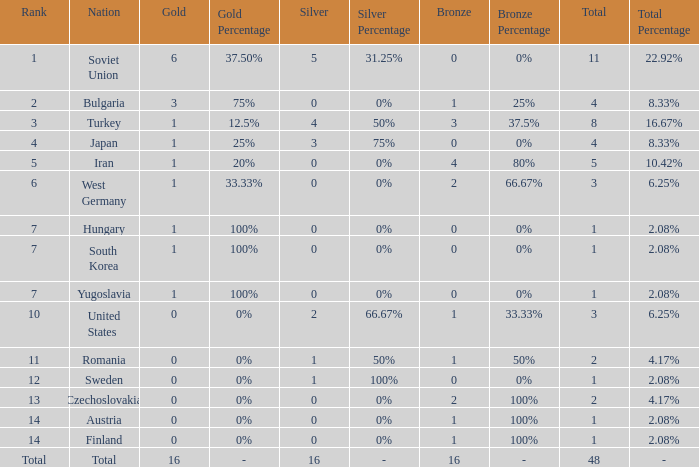How many total golds do teams have when the total medals is less than 1? None. 